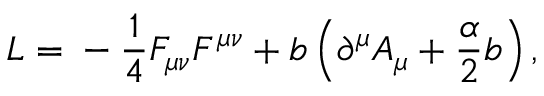Convert formula to latex. <formula><loc_0><loc_0><loc_500><loc_500>L = - \frac { 1 } { 4 } F _ { \mu \nu } F ^ { \mu \nu } + b \left ( \partial ^ { \mu } A _ { \mu } + \frac { \alpha } { 2 } b \right ) ,</formula> 